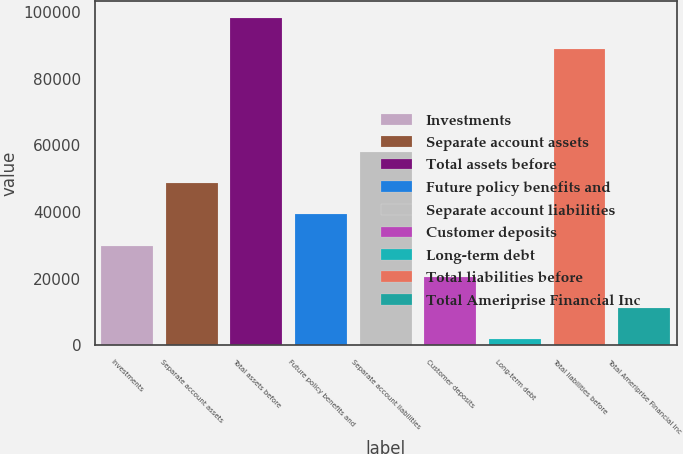Convert chart to OTSL. <chart><loc_0><loc_0><loc_500><loc_500><bar_chart><fcel>Investments<fcel>Separate account assets<fcel>Total assets before<fcel>Future policy benefits and<fcel>Separate account liabilities<fcel>Customer deposits<fcel>Long-term debt<fcel>Total liabilities before<fcel>Total Ameriprise Financial Inc<nl><fcel>29936.2<fcel>48585<fcel>98373.4<fcel>39260.6<fcel>57909.4<fcel>20611.8<fcel>1963<fcel>89049<fcel>11287.4<nl></chart> 